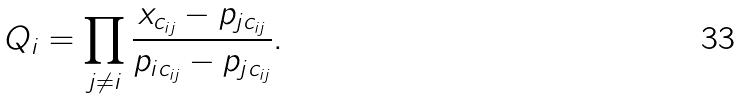Convert formula to latex. <formula><loc_0><loc_0><loc_500><loc_500>Q _ { i } = \prod _ { j \ne i } \frac { x _ { c _ { i j } } - p _ { j c _ { i j } } } { p _ { i c _ { i j } } - p _ { j c _ { i j } } } .</formula> 